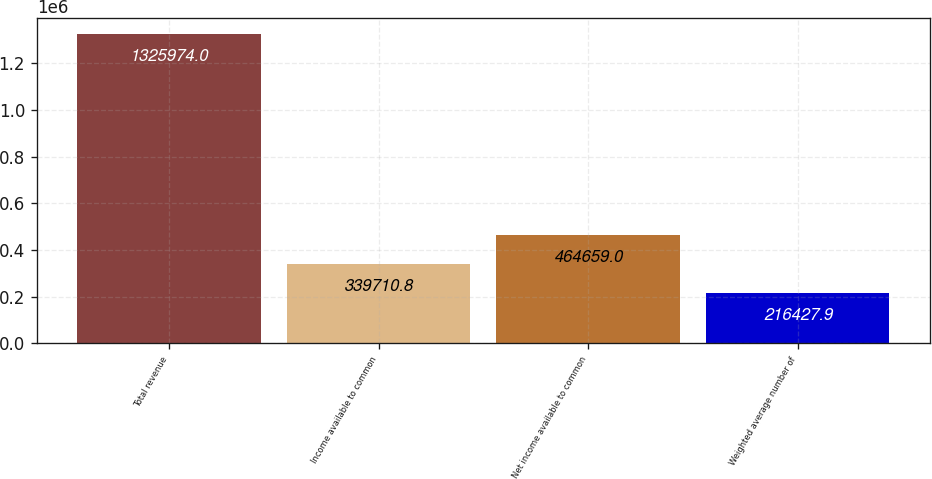Convert chart to OTSL. <chart><loc_0><loc_0><loc_500><loc_500><bar_chart><fcel>Total revenue<fcel>Income available to common<fcel>Net income available to common<fcel>Weighted average number of<nl><fcel>1.32597e+06<fcel>339711<fcel>464659<fcel>216428<nl></chart> 